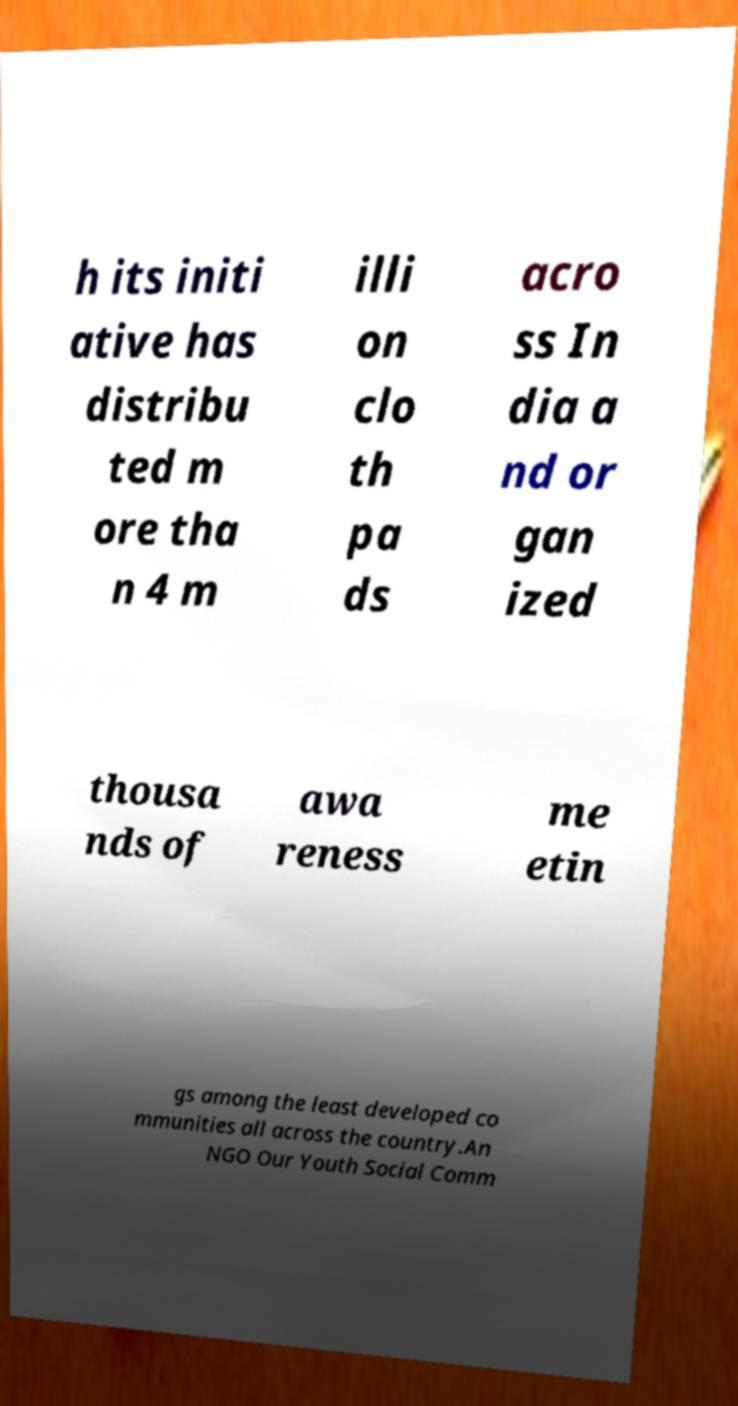Can you accurately transcribe the text from the provided image for me? h its initi ative has distribu ted m ore tha n 4 m illi on clo th pa ds acro ss In dia a nd or gan ized thousa nds of awa reness me etin gs among the least developed co mmunities all across the country.An NGO Our Youth Social Comm 